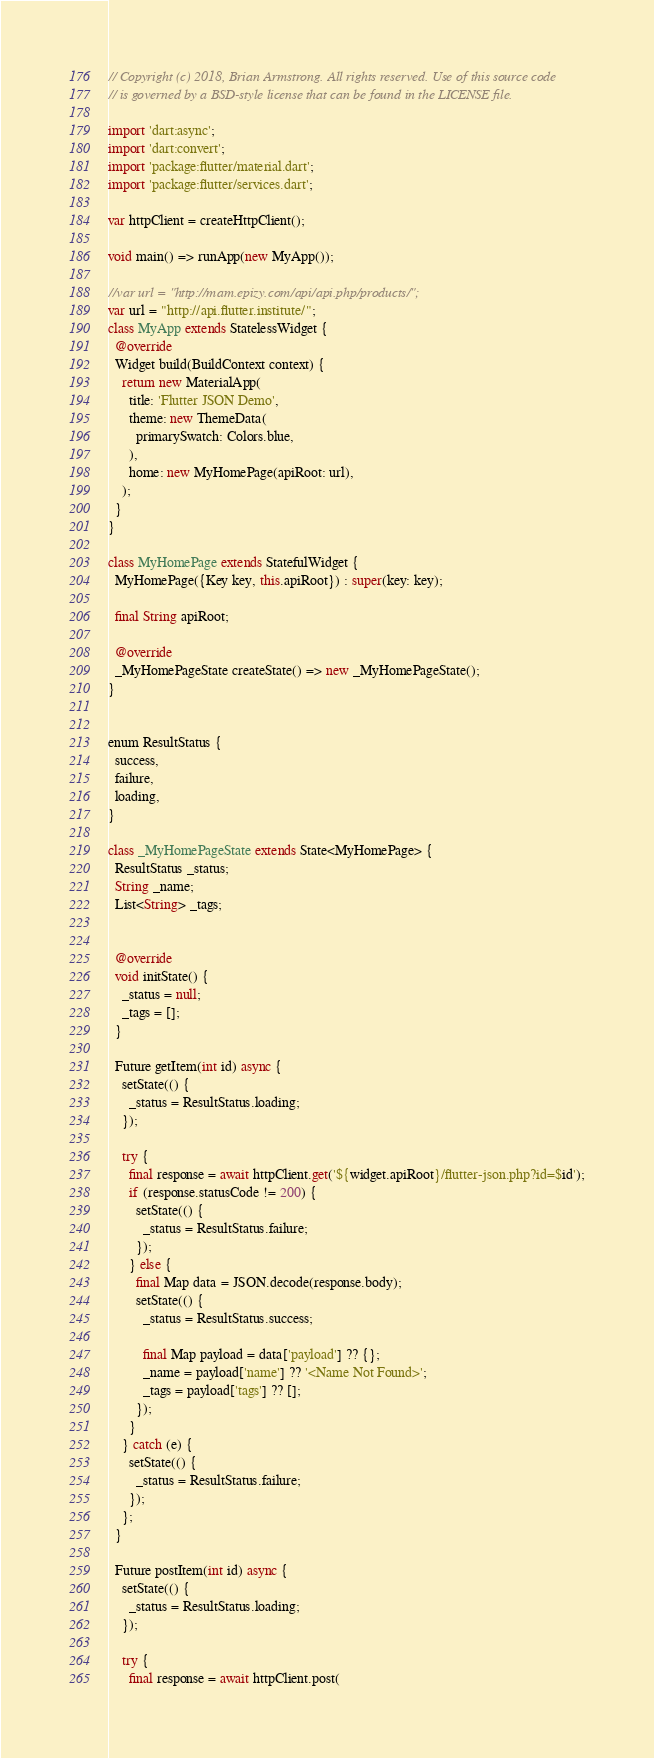Convert code to text. <code><loc_0><loc_0><loc_500><loc_500><_Dart_>// Copyright (c) 2018, Brian Armstrong. All rights reserved. Use of this source code
// is governed by a BSD-style license that can be found in the LICENSE file.

import 'dart:async';
import 'dart:convert';
import 'package:flutter/material.dart';
import 'package:flutter/services.dart';

var httpClient = createHttpClient();

void main() => runApp(new MyApp());

//var url = "http://mam.epizy.com/api/api.php/products/";
var url = "http://api.flutter.institute/";
class MyApp extends StatelessWidget {
  @override
  Widget build(BuildContext context) {
    return new MaterialApp(
      title: 'Flutter JSON Demo',
      theme: new ThemeData(
        primarySwatch: Colors.blue,
      ),
      home: new MyHomePage(apiRoot: url),
    );
  }
}

class MyHomePage extends StatefulWidget {
  MyHomePage({Key key, this.apiRoot}) : super(key: key);

  final String apiRoot;

  @override
  _MyHomePageState createState() => new _MyHomePageState();
}


enum ResultStatus {
  success,
  failure,
  loading,
}

class _MyHomePageState extends State<MyHomePage> {
  ResultStatus _status;
  String _name;
  List<String> _tags;


  @override
  void initState() {
    _status = null;
    _tags = [];
  }

  Future getItem(int id) async {
    setState(() {
      _status = ResultStatus.loading;
    });

    try {
      final response = await httpClient.get('${widget.apiRoot}/flutter-json.php?id=$id');
      if (response.statusCode != 200) {
        setState(() {
          _status = ResultStatus.failure;
        });
      } else {
        final Map data = JSON.decode(response.body);
        setState(() {
          _status = ResultStatus.success;

          final Map payload = data['payload'] ?? {};
          _name = payload['name'] ?? '<Name Not Found>';
          _tags = payload['tags'] ?? [];
        });
      }
    } catch (e) {
      setState(() {
        _status = ResultStatus.failure;
      });
    };
  }

  Future postItem(int id) async {
    setState(() {
      _status = ResultStatus.loading;
    });

    try {
      final response = await httpClient.post(</code> 